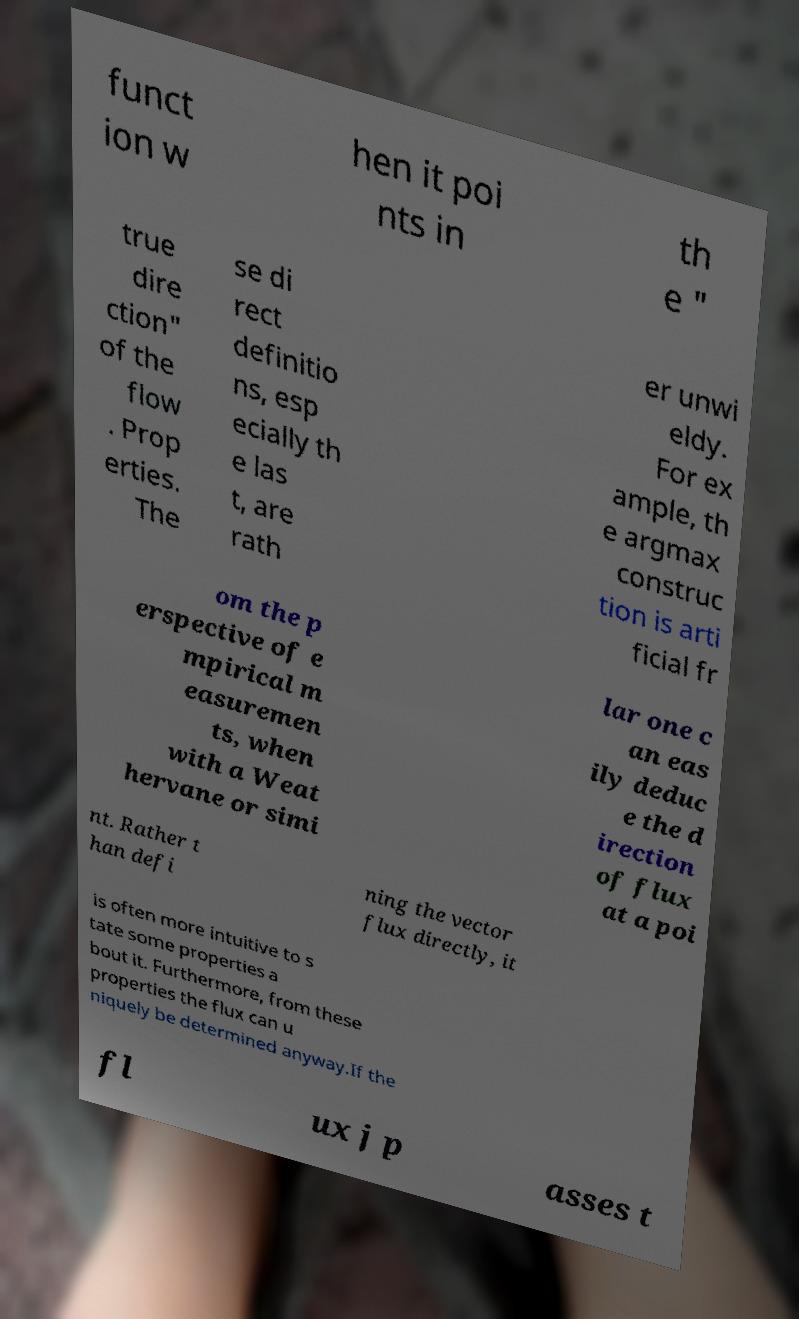Could you extract and type out the text from this image? funct ion w hen it poi nts in th e " true dire ction" of the flow . Prop erties. The se di rect definitio ns, esp ecially th e las t, are rath er unwi eldy. For ex ample, th e argmax construc tion is arti ficial fr om the p erspective of e mpirical m easuremen ts, when with a Weat hervane or simi lar one c an eas ily deduc e the d irection of flux at a poi nt. Rather t han defi ning the vector flux directly, it is often more intuitive to s tate some properties a bout it. Furthermore, from these properties the flux can u niquely be determined anyway.If the fl ux j p asses t 